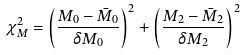<formula> <loc_0><loc_0><loc_500><loc_500>\chi ^ { 2 } _ { M } = \left ( \frac { M _ { 0 } - \bar { M } _ { 0 } } { \delta M _ { 0 } } \right ) ^ { 2 } + \left ( \frac { M _ { 2 } - \bar { M } _ { 2 } } { \delta M _ { 2 } } \right ) ^ { 2 }</formula> 